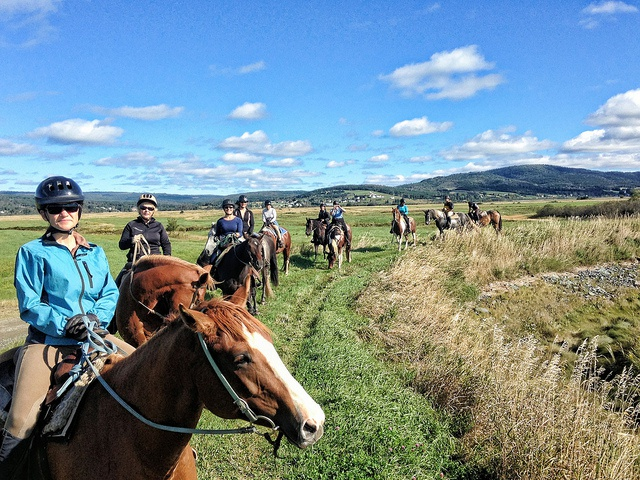Describe the objects in this image and their specific colors. I can see horse in lightblue, black, ivory, gray, and brown tones, people in lightblue, black, and tan tones, horse in lightblue, black, maroon, and brown tones, horse in lightblue, black, and gray tones, and people in lightblue, black, gray, and beige tones in this image. 